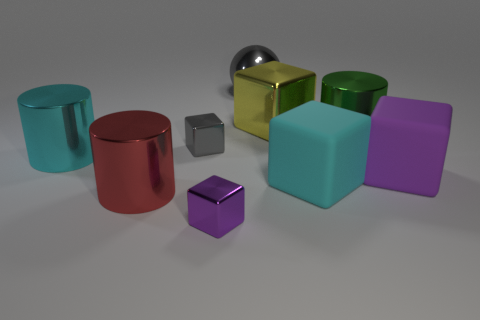Subtract all large yellow metallic blocks. How many blocks are left? 4 Subtract all purple cubes. How many cubes are left? 3 Subtract all cylinders. How many objects are left? 6 Subtract 1 blocks. How many blocks are left? 4 Subtract all yellow balls. Subtract all brown cubes. How many balls are left? 1 Subtract all gray balls. How many gray blocks are left? 1 Subtract all cyan metallic cylinders. Subtract all purple things. How many objects are left? 6 Add 6 cyan rubber cubes. How many cyan rubber cubes are left? 7 Add 5 tiny purple blocks. How many tiny purple blocks exist? 6 Subtract 0 brown cylinders. How many objects are left? 9 